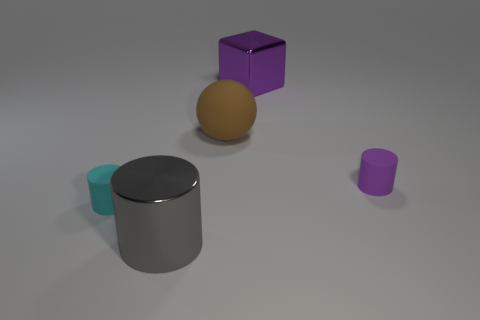Add 1 cyan shiny cylinders. How many objects exist? 6 Subtract all balls. How many objects are left? 4 Subtract 1 purple cubes. How many objects are left? 4 Subtract all big purple metal cylinders. Subtract all gray cylinders. How many objects are left? 4 Add 1 large brown rubber objects. How many large brown rubber objects are left? 2 Add 2 tiny blue cylinders. How many tiny blue cylinders exist? 2 